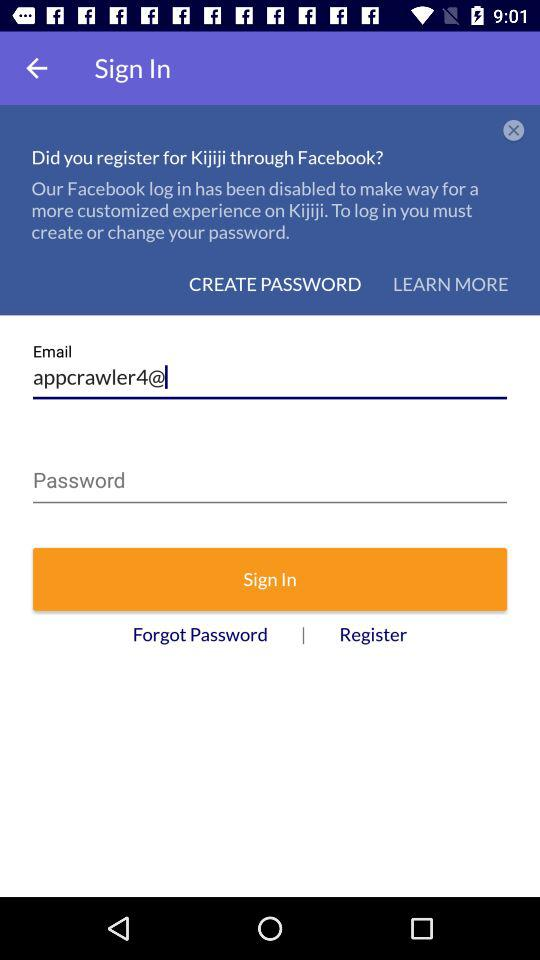How many people have looked into it?
When the provided information is insufficient, respond with <no answer>. <no answer> 